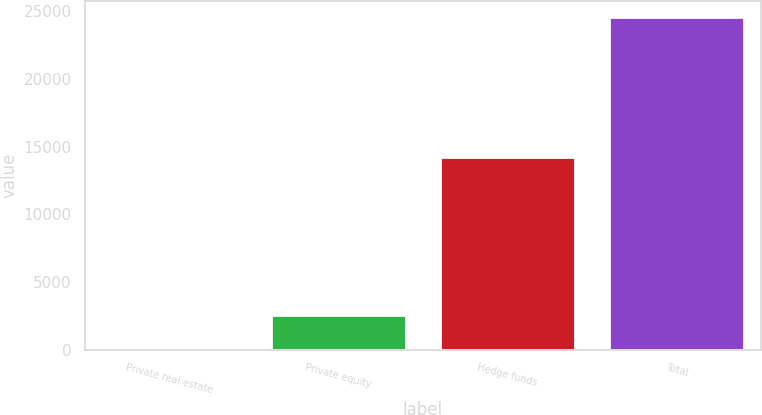Convert chart to OTSL. <chart><loc_0><loc_0><loc_500><loc_500><bar_chart><fcel>Private real estate<fcel>Private equity<fcel>Hedge funds<fcel>Total<nl><fcel>125<fcel>2569<fcel>14258<fcel>24565<nl></chart> 